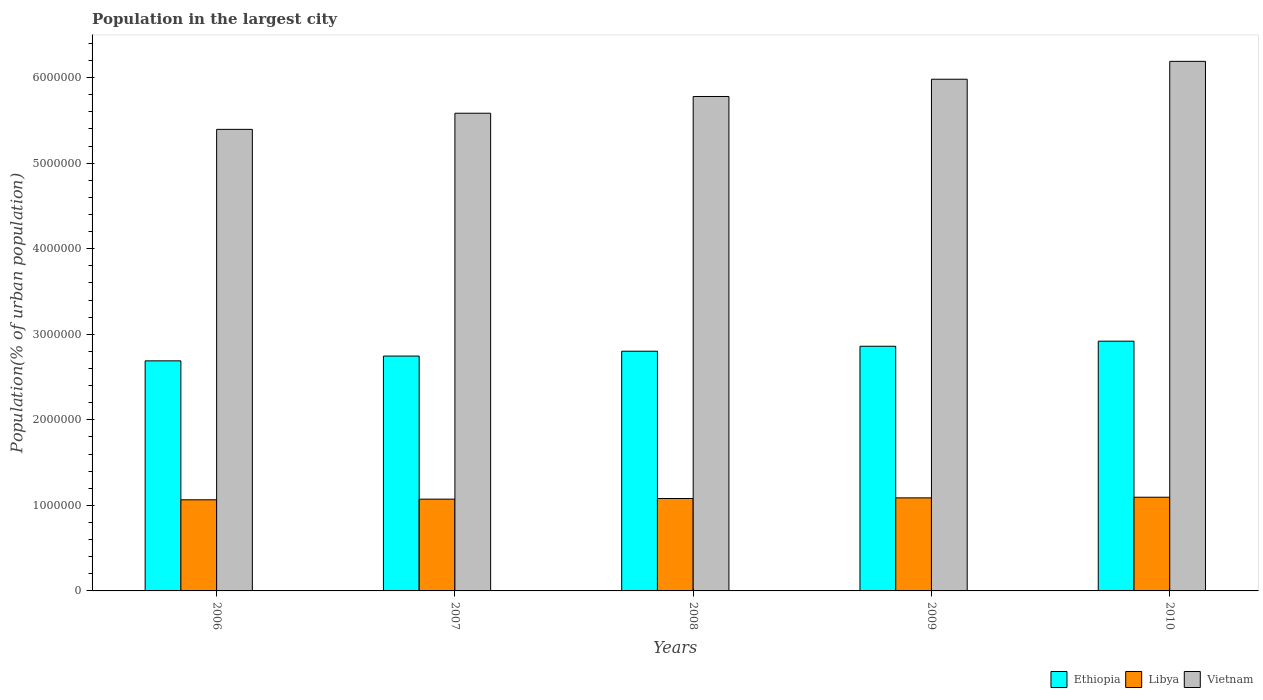How many different coloured bars are there?
Give a very brief answer. 3. How many groups of bars are there?
Offer a terse response. 5. Are the number of bars per tick equal to the number of legend labels?
Keep it short and to the point. Yes. Are the number of bars on each tick of the X-axis equal?
Offer a terse response. Yes. How many bars are there on the 5th tick from the left?
Offer a very short reply. 3. How many bars are there on the 3rd tick from the right?
Make the answer very short. 3. What is the label of the 1st group of bars from the left?
Give a very brief answer. 2006. What is the population in the largest city in Libya in 2010?
Your answer should be compact. 1.10e+06. Across all years, what is the maximum population in the largest city in Ethiopia?
Your answer should be compact. 2.92e+06. Across all years, what is the minimum population in the largest city in Vietnam?
Your response must be concise. 5.39e+06. In which year was the population in the largest city in Ethiopia maximum?
Give a very brief answer. 2010. What is the total population in the largest city in Libya in the graph?
Your answer should be very brief. 5.40e+06. What is the difference between the population in the largest city in Ethiopia in 2007 and that in 2008?
Your answer should be very brief. -5.69e+04. What is the difference between the population in the largest city in Libya in 2007 and the population in the largest city in Ethiopia in 2010?
Your answer should be compact. -1.85e+06. What is the average population in the largest city in Vietnam per year?
Provide a succinct answer. 5.79e+06. In the year 2007, what is the difference between the population in the largest city in Libya and population in the largest city in Ethiopia?
Your response must be concise. -1.67e+06. In how many years, is the population in the largest city in Ethiopia greater than 3600000 %?
Keep it short and to the point. 0. What is the ratio of the population in the largest city in Ethiopia in 2006 to that in 2008?
Make the answer very short. 0.96. Is the difference between the population in the largest city in Libya in 2006 and 2008 greater than the difference between the population in the largest city in Ethiopia in 2006 and 2008?
Provide a short and direct response. Yes. What is the difference between the highest and the second highest population in the largest city in Vietnam?
Make the answer very short. 2.09e+05. What is the difference between the highest and the lowest population in the largest city in Libya?
Give a very brief answer. 3.00e+04. In how many years, is the population in the largest city in Ethiopia greater than the average population in the largest city in Ethiopia taken over all years?
Provide a short and direct response. 2. What does the 2nd bar from the left in 2009 represents?
Your answer should be compact. Libya. What does the 1st bar from the right in 2009 represents?
Provide a succinct answer. Vietnam. How many bars are there?
Your answer should be compact. 15. Are all the bars in the graph horizontal?
Provide a succinct answer. No. How many years are there in the graph?
Keep it short and to the point. 5. Are the values on the major ticks of Y-axis written in scientific E-notation?
Ensure brevity in your answer.  No. Does the graph contain grids?
Keep it short and to the point. No. What is the title of the graph?
Your answer should be compact. Population in the largest city. What is the label or title of the Y-axis?
Ensure brevity in your answer.  Population(% of urban population). What is the Population(% of urban population) of Ethiopia in 2006?
Make the answer very short. 2.69e+06. What is the Population(% of urban population) in Libya in 2006?
Give a very brief answer. 1.07e+06. What is the Population(% of urban population) in Vietnam in 2006?
Provide a succinct answer. 5.39e+06. What is the Population(% of urban population) of Ethiopia in 2007?
Your answer should be very brief. 2.74e+06. What is the Population(% of urban population) of Libya in 2007?
Keep it short and to the point. 1.07e+06. What is the Population(% of urban population) of Vietnam in 2007?
Offer a terse response. 5.58e+06. What is the Population(% of urban population) of Ethiopia in 2008?
Your answer should be very brief. 2.80e+06. What is the Population(% of urban population) in Libya in 2008?
Keep it short and to the point. 1.08e+06. What is the Population(% of urban population) in Vietnam in 2008?
Give a very brief answer. 5.78e+06. What is the Population(% of urban population) of Ethiopia in 2009?
Your answer should be compact. 2.86e+06. What is the Population(% of urban population) of Libya in 2009?
Offer a terse response. 1.09e+06. What is the Population(% of urban population) of Vietnam in 2009?
Give a very brief answer. 5.98e+06. What is the Population(% of urban population) in Ethiopia in 2010?
Keep it short and to the point. 2.92e+06. What is the Population(% of urban population) of Libya in 2010?
Give a very brief answer. 1.10e+06. What is the Population(% of urban population) in Vietnam in 2010?
Give a very brief answer. 6.19e+06. Across all years, what is the maximum Population(% of urban population) of Ethiopia?
Provide a short and direct response. 2.92e+06. Across all years, what is the maximum Population(% of urban population) of Libya?
Provide a short and direct response. 1.10e+06. Across all years, what is the maximum Population(% of urban population) of Vietnam?
Your response must be concise. 6.19e+06. Across all years, what is the minimum Population(% of urban population) of Ethiopia?
Offer a terse response. 2.69e+06. Across all years, what is the minimum Population(% of urban population) in Libya?
Your answer should be compact. 1.07e+06. Across all years, what is the minimum Population(% of urban population) in Vietnam?
Give a very brief answer. 5.39e+06. What is the total Population(% of urban population) in Ethiopia in the graph?
Provide a short and direct response. 1.40e+07. What is the total Population(% of urban population) of Libya in the graph?
Provide a succinct answer. 5.40e+06. What is the total Population(% of urban population) in Vietnam in the graph?
Ensure brevity in your answer.  2.89e+07. What is the difference between the Population(% of urban population) in Ethiopia in 2006 and that in 2007?
Your response must be concise. -5.59e+04. What is the difference between the Population(% of urban population) of Libya in 2006 and that in 2007?
Make the answer very short. -7426. What is the difference between the Population(% of urban population) of Vietnam in 2006 and that in 2007?
Give a very brief answer. -1.89e+05. What is the difference between the Population(% of urban population) of Ethiopia in 2006 and that in 2008?
Provide a succinct answer. -1.13e+05. What is the difference between the Population(% of urban population) in Libya in 2006 and that in 2008?
Your answer should be compact. -1.49e+04. What is the difference between the Population(% of urban population) in Vietnam in 2006 and that in 2008?
Provide a short and direct response. -3.84e+05. What is the difference between the Population(% of urban population) of Ethiopia in 2006 and that in 2009?
Offer a very short reply. -1.71e+05. What is the difference between the Population(% of urban population) in Libya in 2006 and that in 2009?
Keep it short and to the point. -2.24e+04. What is the difference between the Population(% of urban population) in Vietnam in 2006 and that in 2009?
Offer a terse response. -5.86e+05. What is the difference between the Population(% of urban population) of Ethiopia in 2006 and that in 2010?
Your answer should be compact. -2.30e+05. What is the difference between the Population(% of urban population) in Libya in 2006 and that in 2010?
Your response must be concise. -3.00e+04. What is the difference between the Population(% of urban population) in Vietnam in 2006 and that in 2010?
Offer a very short reply. -7.95e+05. What is the difference between the Population(% of urban population) of Ethiopia in 2007 and that in 2008?
Keep it short and to the point. -5.69e+04. What is the difference between the Population(% of urban population) of Libya in 2007 and that in 2008?
Keep it short and to the point. -7479. What is the difference between the Population(% of urban population) of Vietnam in 2007 and that in 2008?
Offer a very short reply. -1.96e+05. What is the difference between the Population(% of urban population) of Ethiopia in 2007 and that in 2009?
Your response must be concise. -1.15e+05. What is the difference between the Population(% of urban population) in Libya in 2007 and that in 2009?
Keep it short and to the point. -1.50e+04. What is the difference between the Population(% of urban population) in Vietnam in 2007 and that in 2009?
Provide a short and direct response. -3.97e+05. What is the difference between the Population(% of urban population) in Ethiopia in 2007 and that in 2010?
Provide a short and direct response. -1.74e+05. What is the difference between the Population(% of urban population) in Libya in 2007 and that in 2010?
Give a very brief answer. -2.26e+04. What is the difference between the Population(% of urban population) in Vietnam in 2007 and that in 2010?
Make the answer very short. -6.06e+05. What is the difference between the Population(% of urban population) in Ethiopia in 2008 and that in 2009?
Your answer should be compact. -5.79e+04. What is the difference between the Population(% of urban population) of Libya in 2008 and that in 2009?
Give a very brief answer. -7530. What is the difference between the Population(% of urban population) in Vietnam in 2008 and that in 2009?
Your response must be concise. -2.02e+05. What is the difference between the Population(% of urban population) of Ethiopia in 2008 and that in 2010?
Provide a succinct answer. -1.17e+05. What is the difference between the Population(% of urban population) of Libya in 2008 and that in 2010?
Keep it short and to the point. -1.51e+04. What is the difference between the Population(% of urban population) of Vietnam in 2008 and that in 2010?
Your answer should be very brief. -4.11e+05. What is the difference between the Population(% of urban population) in Ethiopia in 2009 and that in 2010?
Provide a succinct answer. -5.92e+04. What is the difference between the Population(% of urban population) in Libya in 2009 and that in 2010?
Offer a very short reply. -7583. What is the difference between the Population(% of urban population) of Vietnam in 2009 and that in 2010?
Make the answer very short. -2.09e+05. What is the difference between the Population(% of urban population) in Ethiopia in 2006 and the Population(% of urban population) in Libya in 2007?
Offer a very short reply. 1.62e+06. What is the difference between the Population(% of urban population) of Ethiopia in 2006 and the Population(% of urban population) of Vietnam in 2007?
Provide a short and direct response. -2.89e+06. What is the difference between the Population(% of urban population) of Libya in 2006 and the Population(% of urban population) of Vietnam in 2007?
Offer a very short reply. -4.52e+06. What is the difference between the Population(% of urban population) in Ethiopia in 2006 and the Population(% of urban population) in Libya in 2008?
Give a very brief answer. 1.61e+06. What is the difference between the Population(% of urban population) of Ethiopia in 2006 and the Population(% of urban population) of Vietnam in 2008?
Provide a succinct answer. -3.09e+06. What is the difference between the Population(% of urban population) of Libya in 2006 and the Population(% of urban population) of Vietnam in 2008?
Make the answer very short. -4.71e+06. What is the difference between the Population(% of urban population) in Ethiopia in 2006 and the Population(% of urban population) in Libya in 2009?
Keep it short and to the point. 1.60e+06. What is the difference between the Population(% of urban population) of Ethiopia in 2006 and the Population(% of urban population) of Vietnam in 2009?
Ensure brevity in your answer.  -3.29e+06. What is the difference between the Population(% of urban population) in Libya in 2006 and the Population(% of urban population) in Vietnam in 2009?
Ensure brevity in your answer.  -4.92e+06. What is the difference between the Population(% of urban population) of Ethiopia in 2006 and the Population(% of urban population) of Libya in 2010?
Keep it short and to the point. 1.59e+06. What is the difference between the Population(% of urban population) of Ethiopia in 2006 and the Population(% of urban population) of Vietnam in 2010?
Offer a terse response. -3.50e+06. What is the difference between the Population(% of urban population) in Libya in 2006 and the Population(% of urban population) in Vietnam in 2010?
Ensure brevity in your answer.  -5.12e+06. What is the difference between the Population(% of urban population) of Ethiopia in 2007 and the Population(% of urban population) of Libya in 2008?
Offer a terse response. 1.66e+06. What is the difference between the Population(% of urban population) in Ethiopia in 2007 and the Population(% of urban population) in Vietnam in 2008?
Your response must be concise. -3.03e+06. What is the difference between the Population(% of urban population) in Libya in 2007 and the Population(% of urban population) in Vietnam in 2008?
Keep it short and to the point. -4.71e+06. What is the difference between the Population(% of urban population) in Ethiopia in 2007 and the Population(% of urban population) in Libya in 2009?
Make the answer very short. 1.66e+06. What is the difference between the Population(% of urban population) in Ethiopia in 2007 and the Population(% of urban population) in Vietnam in 2009?
Provide a succinct answer. -3.24e+06. What is the difference between the Population(% of urban population) of Libya in 2007 and the Population(% of urban population) of Vietnam in 2009?
Provide a short and direct response. -4.91e+06. What is the difference between the Population(% of urban population) in Ethiopia in 2007 and the Population(% of urban population) in Libya in 2010?
Keep it short and to the point. 1.65e+06. What is the difference between the Population(% of urban population) in Ethiopia in 2007 and the Population(% of urban population) in Vietnam in 2010?
Provide a short and direct response. -3.44e+06. What is the difference between the Population(% of urban population) of Libya in 2007 and the Population(% of urban population) of Vietnam in 2010?
Your response must be concise. -5.12e+06. What is the difference between the Population(% of urban population) of Ethiopia in 2008 and the Population(% of urban population) of Libya in 2009?
Offer a very short reply. 1.71e+06. What is the difference between the Population(% of urban population) in Ethiopia in 2008 and the Population(% of urban population) in Vietnam in 2009?
Make the answer very short. -3.18e+06. What is the difference between the Population(% of urban population) of Libya in 2008 and the Population(% of urban population) of Vietnam in 2009?
Your answer should be very brief. -4.90e+06. What is the difference between the Population(% of urban population) of Ethiopia in 2008 and the Population(% of urban population) of Libya in 2010?
Your response must be concise. 1.71e+06. What is the difference between the Population(% of urban population) in Ethiopia in 2008 and the Population(% of urban population) in Vietnam in 2010?
Provide a succinct answer. -3.39e+06. What is the difference between the Population(% of urban population) of Libya in 2008 and the Population(% of urban population) of Vietnam in 2010?
Provide a succinct answer. -5.11e+06. What is the difference between the Population(% of urban population) in Ethiopia in 2009 and the Population(% of urban population) in Libya in 2010?
Give a very brief answer. 1.76e+06. What is the difference between the Population(% of urban population) of Ethiopia in 2009 and the Population(% of urban population) of Vietnam in 2010?
Make the answer very short. -3.33e+06. What is the difference between the Population(% of urban population) in Libya in 2009 and the Population(% of urban population) in Vietnam in 2010?
Ensure brevity in your answer.  -5.10e+06. What is the average Population(% of urban population) of Ethiopia per year?
Offer a very short reply. 2.80e+06. What is the average Population(% of urban population) of Libya per year?
Offer a terse response. 1.08e+06. What is the average Population(% of urban population) in Vietnam per year?
Give a very brief answer. 5.79e+06. In the year 2006, what is the difference between the Population(% of urban population) in Ethiopia and Population(% of urban population) in Libya?
Provide a succinct answer. 1.62e+06. In the year 2006, what is the difference between the Population(% of urban population) in Ethiopia and Population(% of urban population) in Vietnam?
Your answer should be compact. -2.71e+06. In the year 2006, what is the difference between the Population(% of urban population) of Libya and Population(% of urban population) of Vietnam?
Your answer should be very brief. -4.33e+06. In the year 2007, what is the difference between the Population(% of urban population) of Ethiopia and Population(% of urban population) of Libya?
Make the answer very short. 1.67e+06. In the year 2007, what is the difference between the Population(% of urban population) in Ethiopia and Population(% of urban population) in Vietnam?
Offer a very short reply. -2.84e+06. In the year 2007, what is the difference between the Population(% of urban population) of Libya and Population(% of urban population) of Vietnam?
Your answer should be very brief. -4.51e+06. In the year 2008, what is the difference between the Population(% of urban population) of Ethiopia and Population(% of urban population) of Libya?
Offer a terse response. 1.72e+06. In the year 2008, what is the difference between the Population(% of urban population) in Ethiopia and Population(% of urban population) in Vietnam?
Make the answer very short. -2.98e+06. In the year 2008, what is the difference between the Population(% of urban population) in Libya and Population(% of urban population) in Vietnam?
Offer a terse response. -4.70e+06. In the year 2009, what is the difference between the Population(% of urban population) in Ethiopia and Population(% of urban population) in Libya?
Provide a succinct answer. 1.77e+06. In the year 2009, what is the difference between the Population(% of urban population) of Ethiopia and Population(% of urban population) of Vietnam?
Provide a short and direct response. -3.12e+06. In the year 2009, what is the difference between the Population(% of urban population) of Libya and Population(% of urban population) of Vietnam?
Your answer should be very brief. -4.89e+06. In the year 2010, what is the difference between the Population(% of urban population) in Ethiopia and Population(% of urban population) in Libya?
Offer a very short reply. 1.82e+06. In the year 2010, what is the difference between the Population(% of urban population) in Ethiopia and Population(% of urban population) in Vietnam?
Make the answer very short. -3.27e+06. In the year 2010, what is the difference between the Population(% of urban population) in Libya and Population(% of urban population) in Vietnam?
Offer a terse response. -5.09e+06. What is the ratio of the Population(% of urban population) in Ethiopia in 2006 to that in 2007?
Keep it short and to the point. 0.98. What is the ratio of the Population(% of urban population) in Libya in 2006 to that in 2007?
Ensure brevity in your answer.  0.99. What is the ratio of the Population(% of urban population) of Vietnam in 2006 to that in 2007?
Give a very brief answer. 0.97. What is the ratio of the Population(% of urban population) of Ethiopia in 2006 to that in 2008?
Your response must be concise. 0.96. What is the ratio of the Population(% of urban population) in Libya in 2006 to that in 2008?
Keep it short and to the point. 0.99. What is the ratio of the Population(% of urban population) of Vietnam in 2006 to that in 2008?
Provide a succinct answer. 0.93. What is the ratio of the Population(% of urban population) of Ethiopia in 2006 to that in 2009?
Offer a terse response. 0.94. What is the ratio of the Population(% of urban population) of Libya in 2006 to that in 2009?
Your answer should be compact. 0.98. What is the ratio of the Population(% of urban population) in Vietnam in 2006 to that in 2009?
Your answer should be very brief. 0.9. What is the ratio of the Population(% of urban population) in Ethiopia in 2006 to that in 2010?
Your answer should be compact. 0.92. What is the ratio of the Population(% of urban population) in Libya in 2006 to that in 2010?
Provide a succinct answer. 0.97. What is the ratio of the Population(% of urban population) in Vietnam in 2006 to that in 2010?
Offer a terse response. 0.87. What is the ratio of the Population(% of urban population) in Ethiopia in 2007 to that in 2008?
Offer a very short reply. 0.98. What is the ratio of the Population(% of urban population) of Libya in 2007 to that in 2008?
Your response must be concise. 0.99. What is the ratio of the Population(% of urban population) of Vietnam in 2007 to that in 2008?
Offer a very short reply. 0.97. What is the ratio of the Population(% of urban population) of Ethiopia in 2007 to that in 2009?
Offer a terse response. 0.96. What is the ratio of the Population(% of urban population) in Libya in 2007 to that in 2009?
Offer a very short reply. 0.99. What is the ratio of the Population(% of urban population) in Vietnam in 2007 to that in 2009?
Make the answer very short. 0.93. What is the ratio of the Population(% of urban population) in Ethiopia in 2007 to that in 2010?
Make the answer very short. 0.94. What is the ratio of the Population(% of urban population) of Libya in 2007 to that in 2010?
Your answer should be compact. 0.98. What is the ratio of the Population(% of urban population) of Vietnam in 2007 to that in 2010?
Provide a succinct answer. 0.9. What is the ratio of the Population(% of urban population) of Ethiopia in 2008 to that in 2009?
Offer a very short reply. 0.98. What is the ratio of the Population(% of urban population) in Vietnam in 2008 to that in 2009?
Give a very brief answer. 0.97. What is the ratio of the Population(% of urban population) in Ethiopia in 2008 to that in 2010?
Keep it short and to the point. 0.96. What is the ratio of the Population(% of urban population) of Libya in 2008 to that in 2010?
Offer a terse response. 0.99. What is the ratio of the Population(% of urban population) in Vietnam in 2008 to that in 2010?
Provide a short and direct response. 0.93. What is the ratio of the Population(% of urban population) of Ethiopia in 2009 to that in 2010?
Ensure brevity in your answer.  0.98. What is the ratio of the Population(% of urban population) of Vietnam in 2009 to that in 2010?
Provide a short and direct response. 0.97. What is the difference between the highest and the second highest Population(% of urban population) of Ethiopia?
Ensure brevity in your answer.  5.92e+04. What is the difference between the highest and the second highest Population(% of urban population) in Libya?
Provide a succinct answer. 7583. What is the difference between the highest and the second highest Population(% of urban population) of Vietnam?
Offer a very short reply. 2.09e+05. What is the difference between the highest and the lowest Population(% of urban population) of Ethiopia?
Give a very brief answer. 2.30e+05. What is the difference between the highest and the lowest Population(% of urban population) in Libya?
Ensure brevity in your answer.  3.00e+04. What is the difference between the highest and the lowest Population(% of urban population) of Vietnam?
Provide a succinct answer. 7.95e+05. 